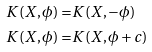Convert formula to latex. <formula><loc_0><loc_0><loc_500><loc_500>K ( X , \phi ) = & K ( X , - \phi ) \\ K ( X , \phi ) = & K ( X , \phi + c ) \\</formula> 